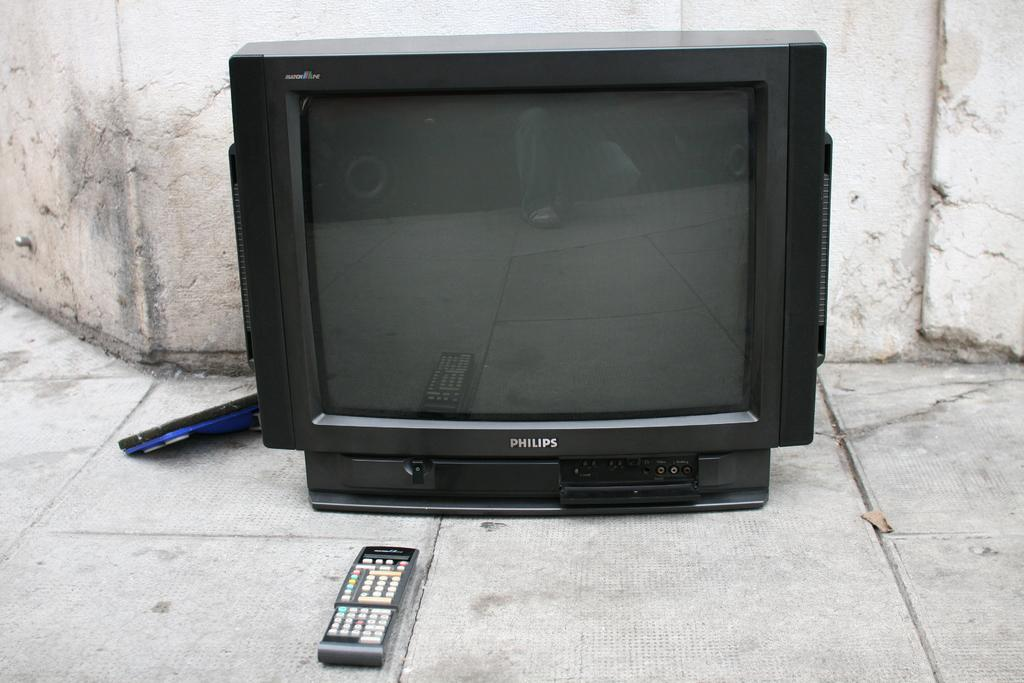<image>
Provide a brief description of the given image. An older Philips television is sitting on the ground along with the remote. 